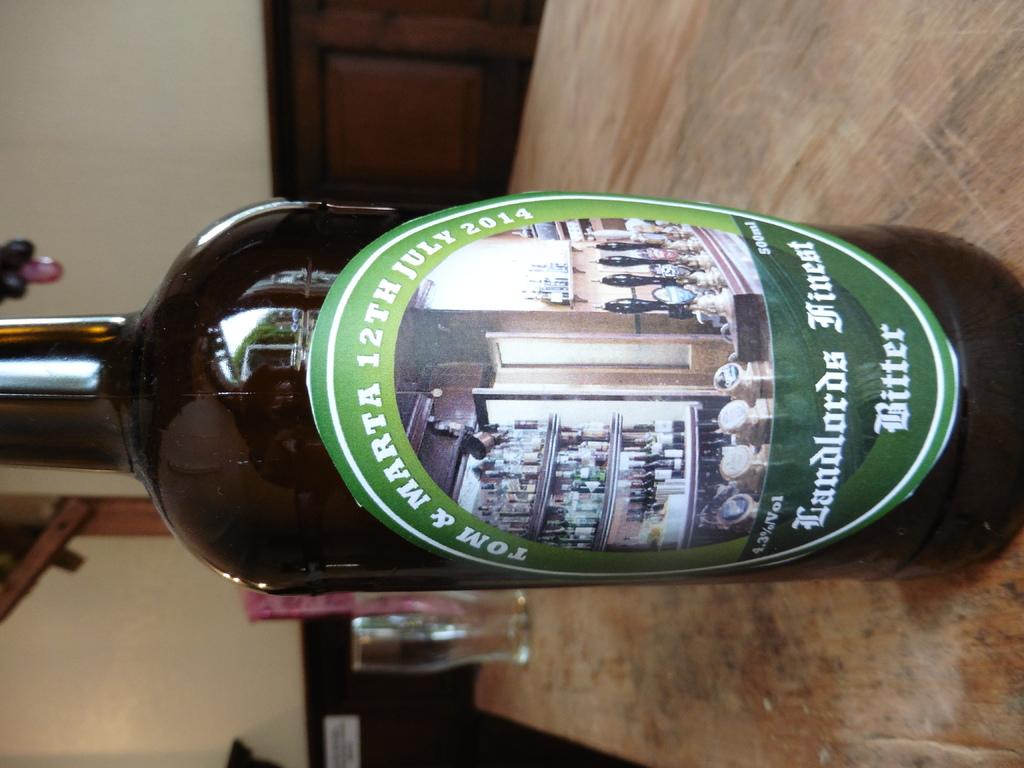<image>
Relay a brief, clear account of the picture shown. A beer bottle of Landlords Fineat Bitter is on a table. 